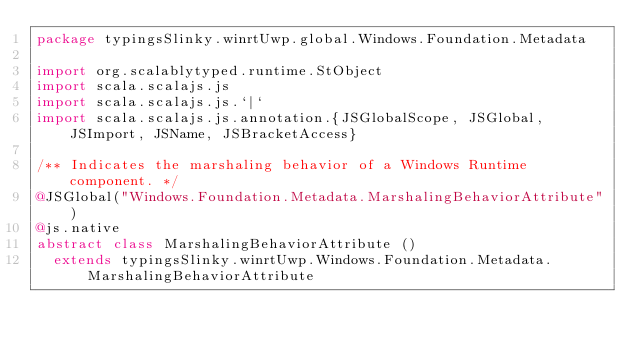<code> <loc_0><loc_0><loc_500><loc_500><_Scala_>package typingsSlinky.winrtUwp.global.Windows.Foundation.Metadata

import org.scalablytyped.runtime.StObject
import scala.scalajs.js
import scala.scalajs.js.`|`
import scala.scalajs.js.annotation.{JSGlobalScope, JSGlobal, JSImport, JSName, JSBracketAccess}

/** Indicates the marshaling behavior of a Windows Runtime component. */
@JSGlobal("Windows.Foundation.Metadata.MarshalingBehaviorAttribute")
@js.native
abstract class MarshalingBehaviorAttribute ()
  extends typingsSlinky.winrtUwp.Windows.Foundation.Metadata.MarshalingBehaviorAttribute
</code> 